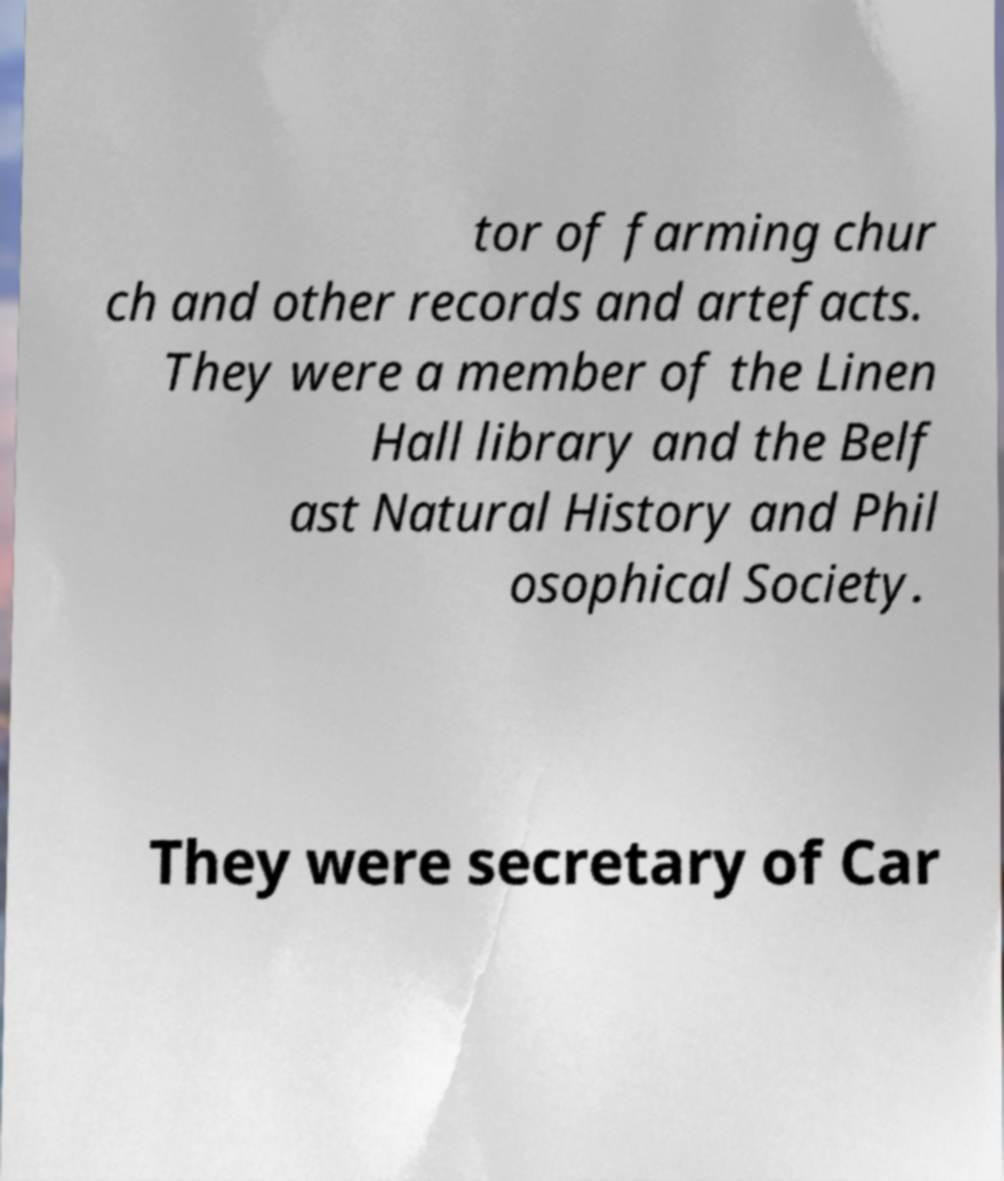There's text embedded in this image that I need extracted. Can you transcribe it verbatim? tor of farming chur ch and other records and artefacts. They were a member of the Linen Hall library and the Belf ast Natural History and Phil osophical Society. They were secretary of Car 